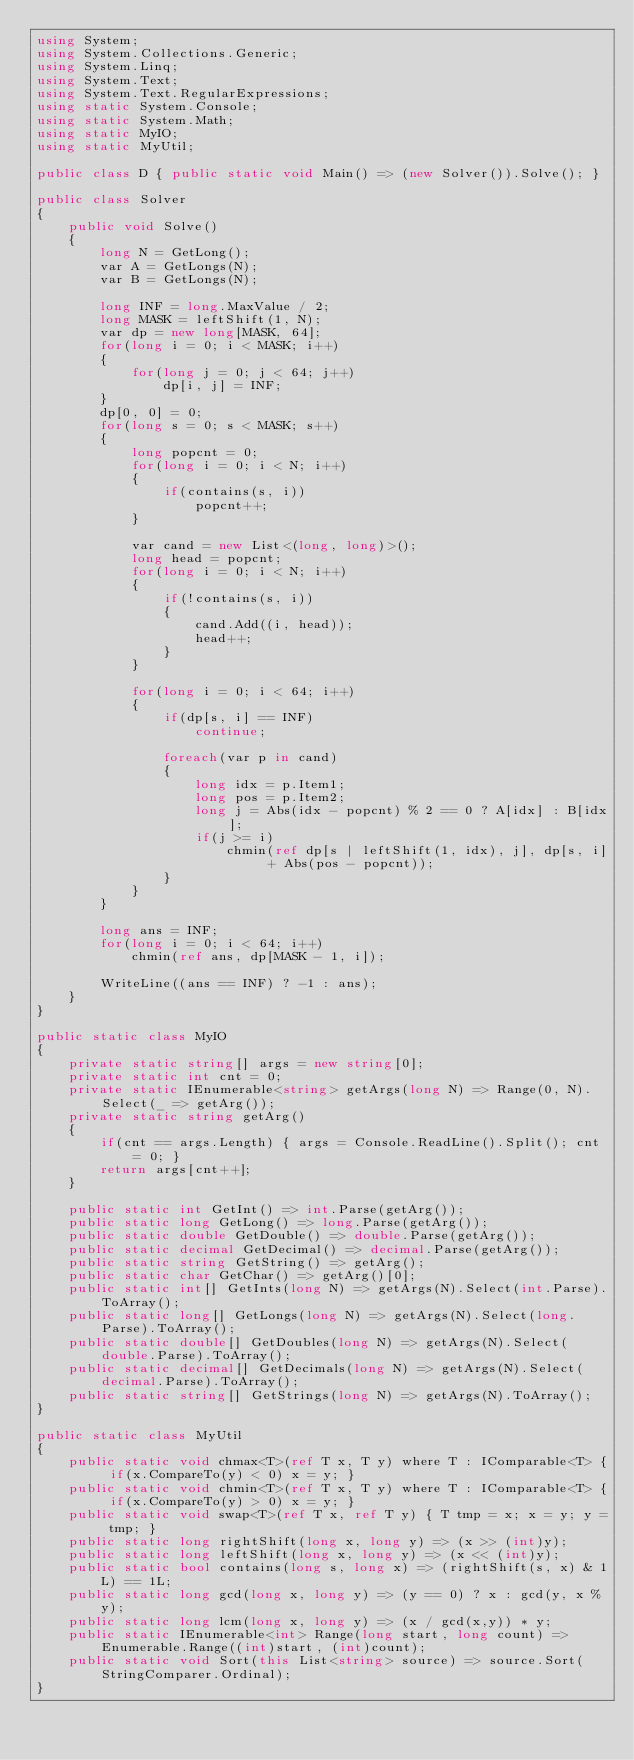<code> <loc_0><loc_0><loc_500><loc_500><_C#_>using System;
using System.Collections.Generic;
using System.Linq;
using System.Text;
using System.Text.RegularExpressions;
using static System.Console;
using static System.Math;
using static MyIO;
using static MyUtil;

public class D { public static void Main() => (new Solver()).Solve(); }

public class Solver
{
	public void Solve()
	{
		long N = GetLong();
		var A = GetLongs(N);
		var B = GetLongs(N);

		long INF = long.MaxValue / 2;
		long MASK = leftShift(1, N);
		var dp = new long[MASK, 64];
		for(long i = 0; i < MASK; i++)
		{
			for(long j = 0; j < 64; j++)
				dp[i, j] = INF;
		}
		dp[0, 0] = 0;
		for(long s = 0; s < MASK; s++)
		{
			long popcnt = 0;
			for(long i = 0; i < N; i++)
			{
				if(contains(s, i))
					popcnt++;
			}

			var cand = new List<(long, long)>();
			long head = popcnt;
			for(long i = 0; i < N; i++)
			{
				if(!contains(s, i))
				{
					cand.Add((i, head));
					head++;
				}
			}

			for(long i = 0; i < 64; i++)
			{
				if(dp[s, i] == INF)
					continue;

				foreach(var p in cand)
				{
					long idx = p.Item1;
					long pos = p.Item2;
					long j = Abs(idx - popcnt) % 2 == 0 ? A[idx] : B[idx];
					if(j >= i)
						chmin(ref dp[s | leftShift(1, idx), j], dp[s, i] + Abs(pos - popcnt));
				}
			}
		}

		long ans = INF;
		for(long i = 0; i < 64; i++)
			chmin(ref ans, dp[MASK - 1, i]);

		WriteLine((ans == INF) ? -1 : ans);
	}
}

public static class MyIO
{
	private static string[] args = new string[0];
	private static int cnt = 0;
	private static IEnumerable<string> getArgs(long N) => Range(0, N).Select(_ => getArg());
	private static string getArg()
	{
		if(cnt == args.Length) { args = Console.ReadLine().Split(); cnt = 0; }
		return args[cnt++];
	}

	public static int GetInt() => int.Parse(getArg());
	public static long GetLong() => long.Parse(getArg());
	public static double GetDouble() => double.Parse(getArg());
	public static decimal GetDecimal() => decimal.Parse(getArg());
	public static string GetString() => getArg();
	public static char GetChar() => getArg()[0];
	public static int[] GetInts(long N) => getArgs(N).Select(int.Parse).ToArray();
	public static long[] GetLongs(long N) => getArgs(N).Select(long.Parse).ToArray();
	public static double[] GetDoubles(long N) => getArgs(N).Select(double.Parse).ToArray();
	public static decimal[] GetDecimals(long N) => getArgs(N).Select(decimal.Parse).ToArray();
	public static string[] GetStrings(long N) => getArgs(N).ToArray();
}

public static class MyUtil
{
	public static void chmax<T>(ref T x, T y) where T : IComparable<T> { if(x.CompareTo(y) < 0) x = y; }
	public static void chmin<T>(ref T x, T y) where T : IComparable<T> { if(x.CompareTo(y) > 0)	x = y; }
	public static void swap<T>(ref T x, ref T y) { T tmp = x; x = y; y = tmp; }
	public static long rightShift(long x, long y) => (x >> (int)y);
	public static long leftShift(long x, long y) => (x << (int)y);
	public static bool contains(long s, long x) => (rightShift(s, x) & 1L) == 1L;
	public static long gcd(long x, long y) => (y == 0) ? x : gcd(y, x % y);
	public static long lcm(long x, long y) => (x / gcd(x,y)) * y;	
	public static IEnumerable<int> Range(long start, long count) => Enumerable.Range((int)start, (int)count);
	public static void Sort(this List<string> source) => source.Sort(StringComparer.Ordinal);
}
</code> 